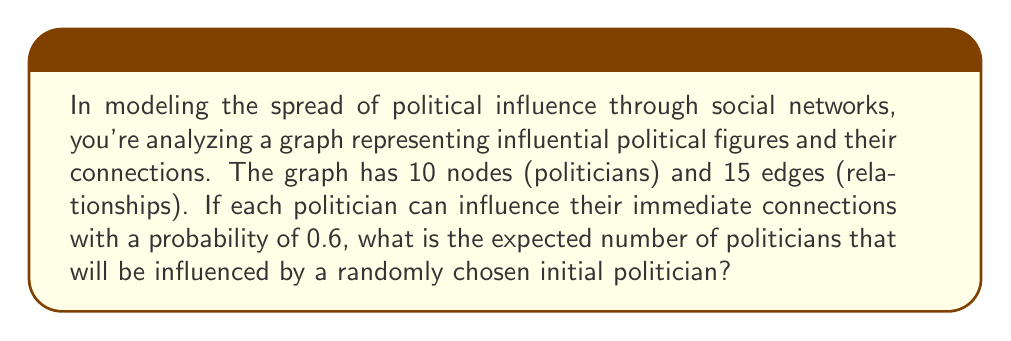Provide a solution to this math problem. To solve this problem, we'll use concepts from graph theory and probability theory:

1) First, we need to calculate the average degree of the graph. The degree of a node is the number of edges connected to it. The average degree is:

   $$\text{Average Degree} = \frac{2 \times \text{Number of Edges}}{\text{Number of Nodes}}$$

   $$\text{Average Degree} = \frac{2 \times 15}{10} = 3$$

2) This means that, on average, each politician is connected to 3 others.

3) The probability of influencing each connection is 0.6. Therefore, the expected number of politicians directly influenced by the initial politician is:

   $$\text{Expected Direct Influence} = 3 \times 0.6 = 1.8$$

4) However, we also need to consider the initial politician themselves, as they are already "influenced". So we add 1 to our result:

   $$\text{Total Expected Influence} = 1.8 + 1 = 2.8$$

This means that, on average, a randomly chosen politician will influence themselves plus 1.8 other politicians, for a total of 2.8 politicians.
Answer: The expected number of politicians influenced is 2.8. 